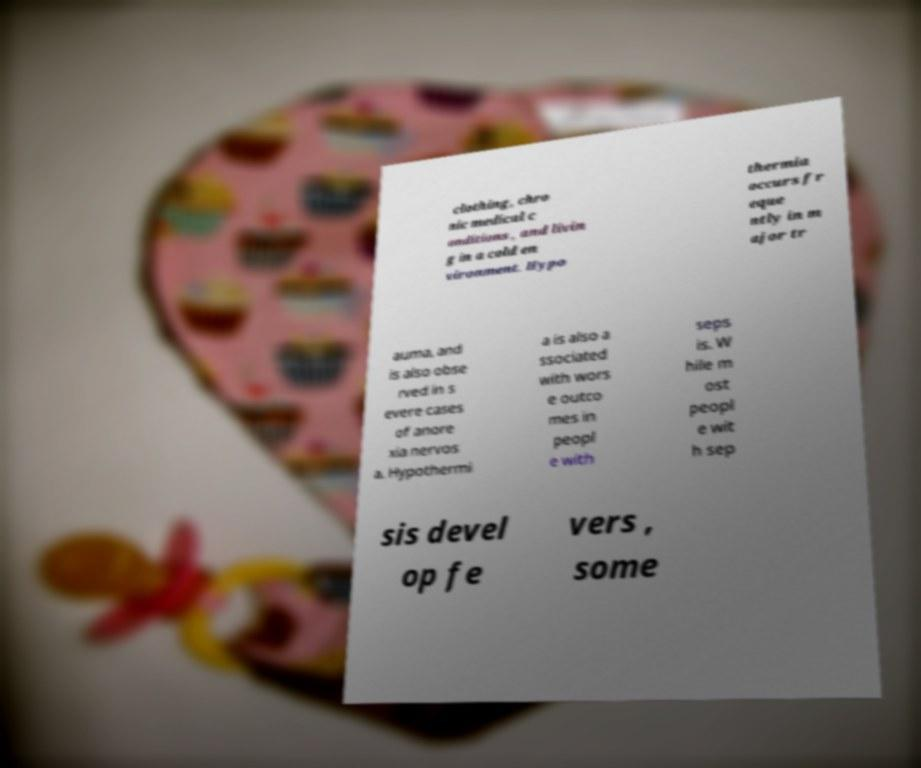There's text embedded in this image that I need extracted. Can you transcribe it verbatim? clothing, chro nic medical c onditions , and livin g in a cold en vironment. Hypo thermia occurs fr eque ntly in m ajor tr auma, and is also obse rved in s evere cases of anore xia nervos a. Hypothermi a is also a ssociated with wors e outco mes in peopl e with seps is. W hile m ost peopl e wit h sep sis devel op fe vers , some 